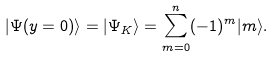<formula> <loc_0><loc_0><loc_500><loc_500>| \Psi ( y = 0 ) \rangle = | \Psi _ { K } \rangle = \sum _ { m = 0 } ^ { n } ( - 1 ) ^ { m } | m \rangle .</formula> 